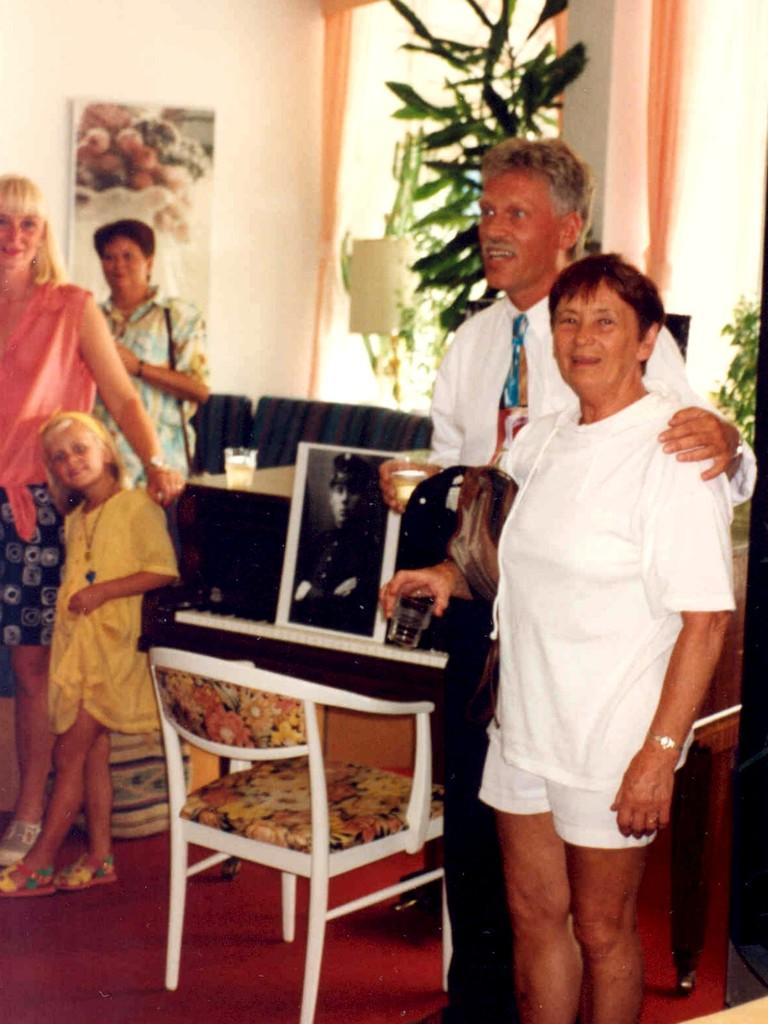How would you summarize this image in a sentence or two? in this image i can see two persons stand on the right side wearing a white color shirts and there are smiling beside them there is a table ,on the table there is a photo frame , back side there is a flower pot and beside it there is wall ,on the wall there is a painting near to the painting a woman stand left side an a girl stand near to the table. on the table there is a glass contain a water. 